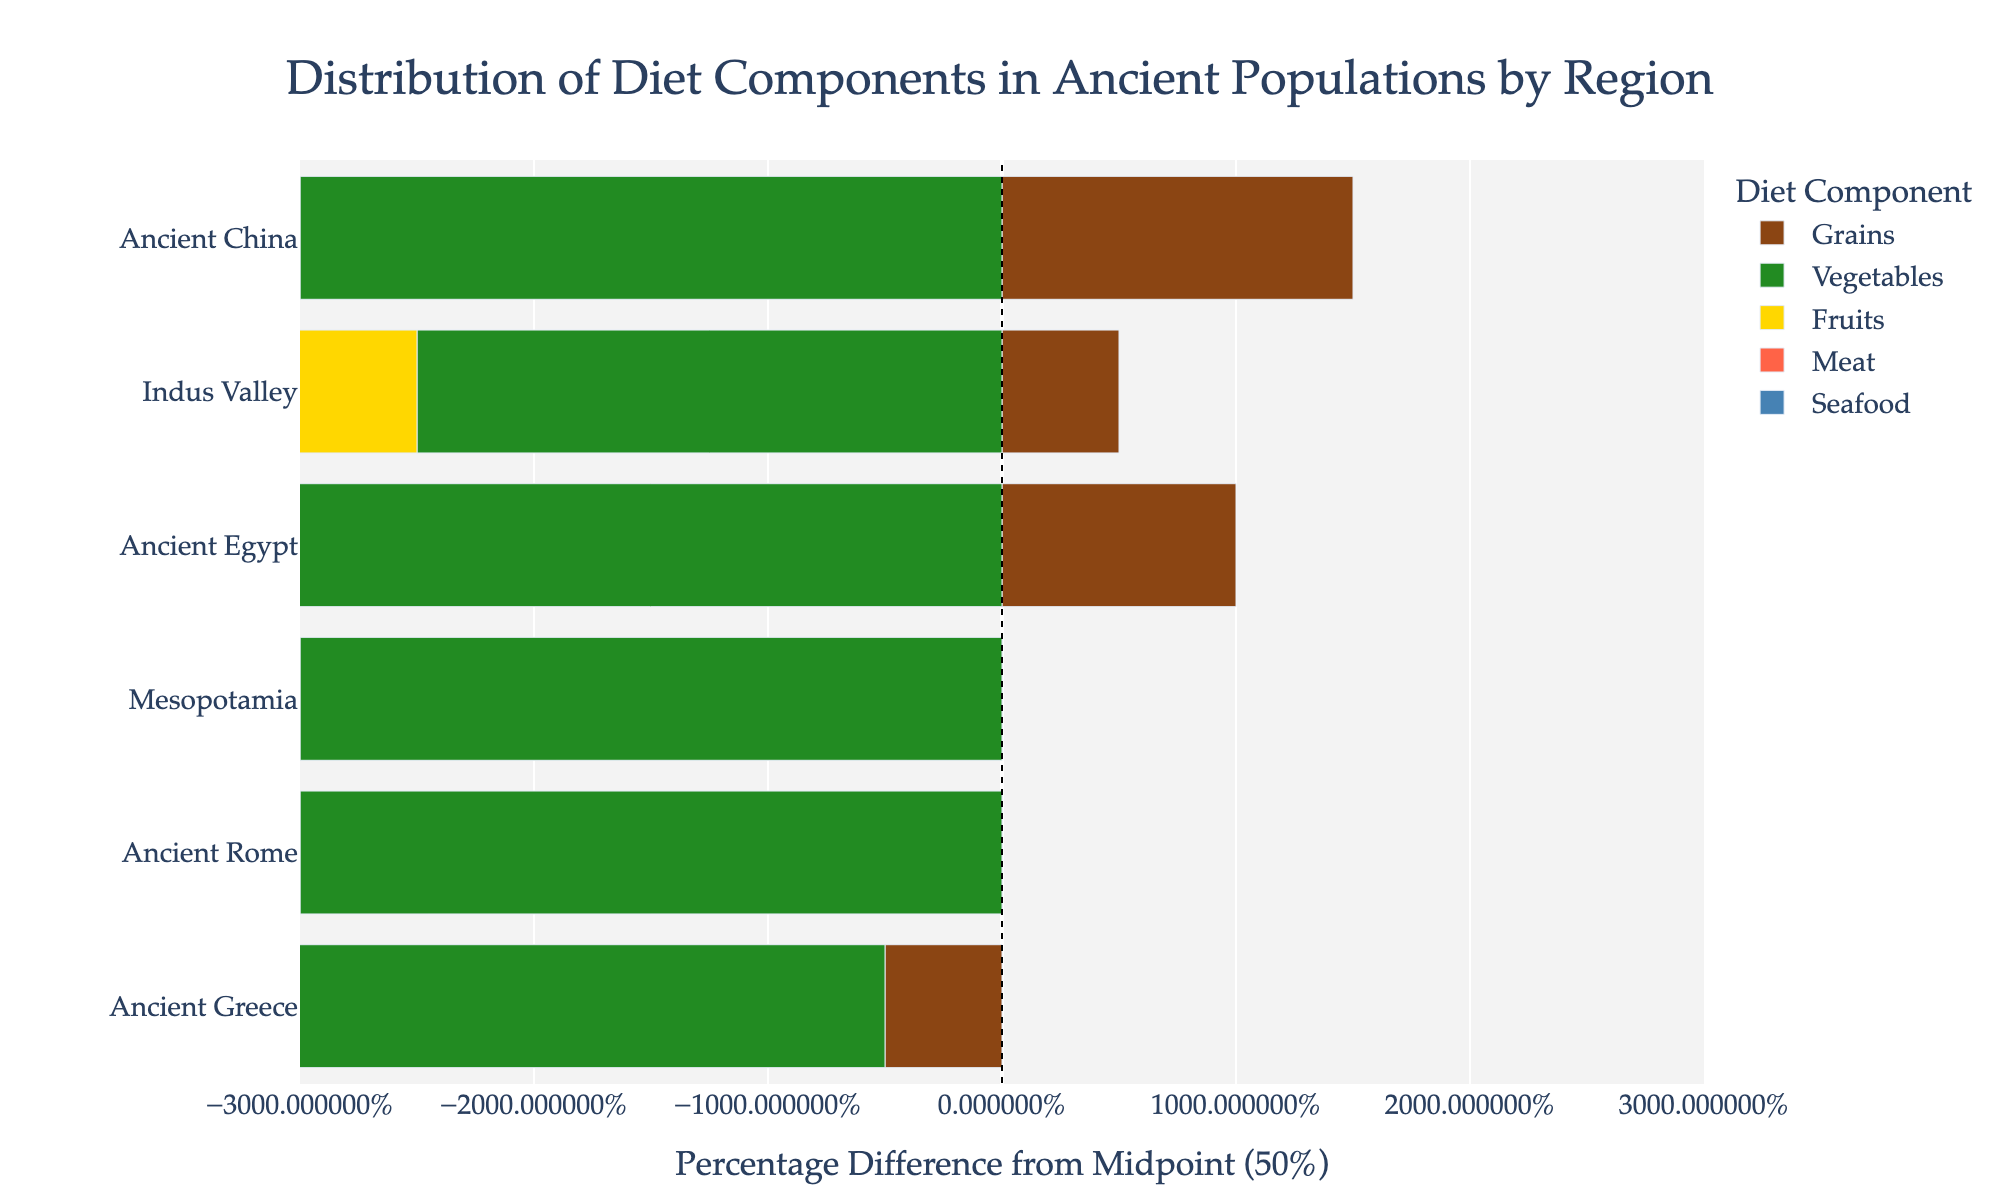Which region has the highest percentage of grains in their diet? From the figure, observe the length of the bars corresponding to "Grains" for each region. The bar for Ancient China extends the furthest, indicating the highest percentage.
Answer: Ancient China What is the total percentage of fruits and vegetables in the diet of Ancient Greece? From the figure, locate Ancient Greece and sum the percentage of the bars for "Fruits" and "Vegetables." Fruits account for 20% and Vegetables account for 20%. Summing these gives 20% + 20% = 40%.
Answer: 40% Which region consumes the least amount of meat? By comparing the “Meat” bars for all regions, the Indus Valley and Ancient China both have the shortest bars, each representing 5%.
Answer: Indus Valley and Ancient China How does the grain consumption in Mesopotamia compare to that of Ancient Rome? Compare the "Grains" bars for Mesopotamia and Ancient Rome. Mesopotamia's grain percentage is 50%, whereas Ancient Rome's grain percentage is also 50%, making them equal.
Answer: Equal Which component has the greatest variability in percentage among all regions? Look at the bars' range for each component across all regions. The "Grains" component varies from 45% to 65%, which shows the most variability.
Answer: Grains What is the percentage difference in grain consumption between Ancient Egypt and Ancient Greece? Ancient Egypt has 60% and Ancient Greece has 45% for grains. The percentage difference is 60% - 45% = 15%.
Answer: 15% What percentage of the diet in Ancient China consists of fruits? Observe the bar for "Fruits" in Ancient China. The length of the bar represents 5%.
Answer: 5% If you combine the percentages for meat and seafood in the Indus Valley, what do you get? Sum the percentages of "Meat" and "Seafood" for the Indus Valley. Meat is 5% and Seafood is 5%. The total is 5% + 5% = 10%.
Answer: 10% Which region has the most balanced diet in terms of the smallest difference between the highest and lowest components? Calculate the difference between the highest and lowest percentages for each region. Ancient Greece has its diet components ranging between 5% and 45%, the smallest difference being 45% - 5% = 40%.
Answer: Ancient Greece 